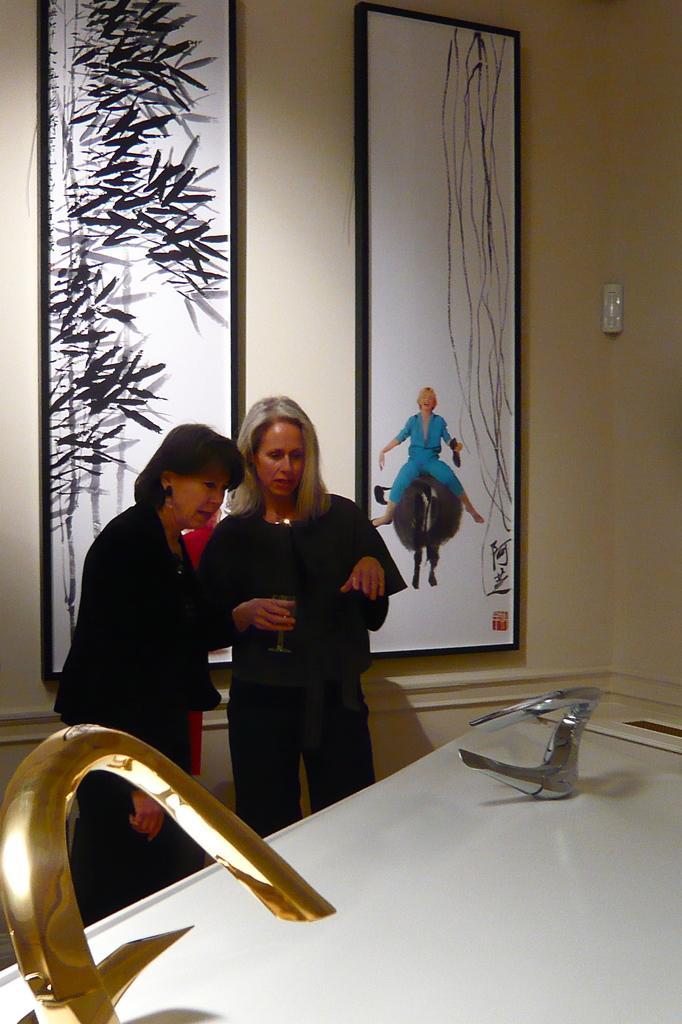How would you summarize this image in a sentence or two? In this image we can see two ladies. One lady is holding a glass. In the background there is a wall with a photo frames. Also we can see tabs on a platform. 